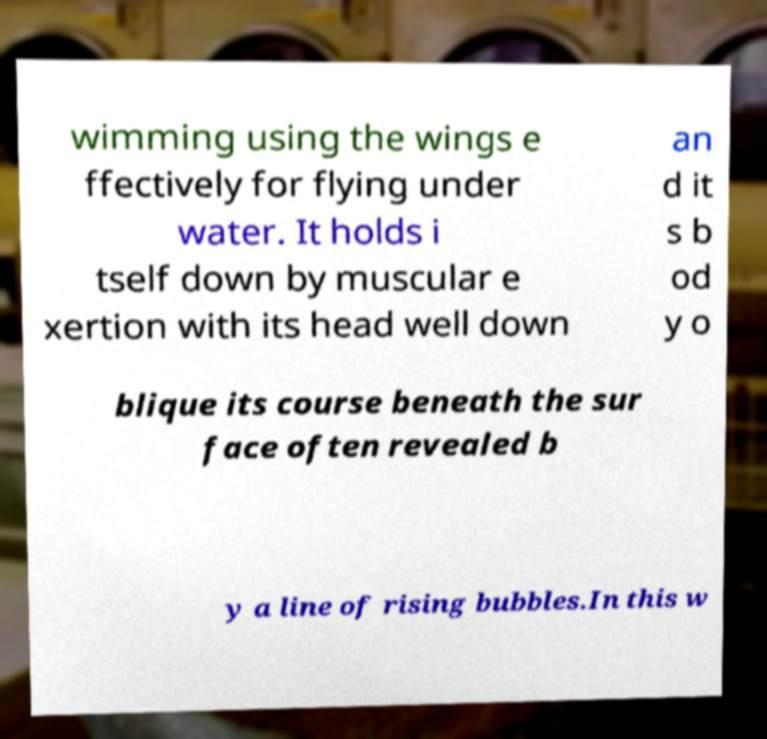What messages or text are displayed in this image? I need them in a readable, typed format. wimming using the wings e ffectively for flying under water. It holds i tself down by muscular e xertion with its head well down an d it s b od y o blique its course beneath the sur face often revealed b y a line of rising bubbles.In this w 